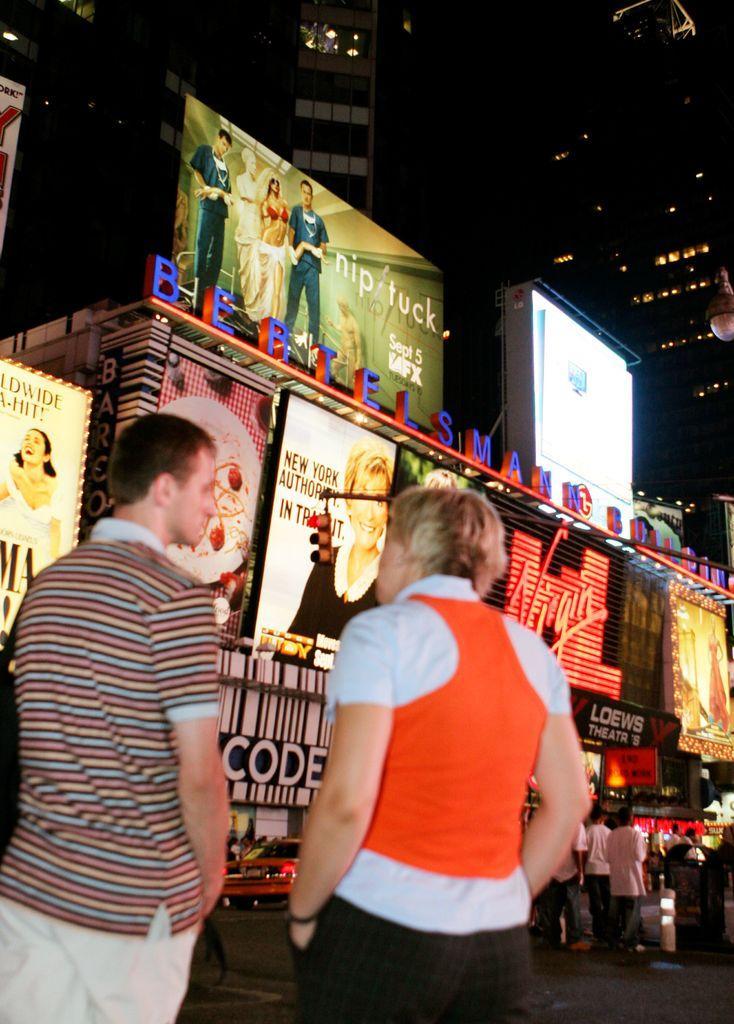How would you summarize this image in a sentence or two? In this image in the foreground there are two persons who are standing, and in the background there are some stores and some people are walking and also there are some boards. In the background there are some buildings and lights, at the bottom there is a walkway and one car. 